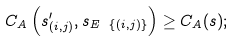<formula> <loc_0><loc_0><loc_500><loc_500>C _ { A } \left ( s _ { ( i , j ) } ^ { \prime } , s _ { E \ \{ ( i , j ) \} } \right ) \geq C _ { A } ( s ) ;</formula> 